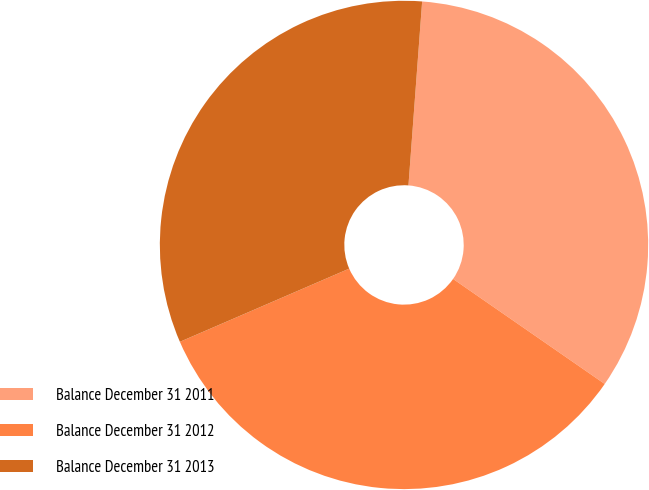<chart> <loc_0><loc_0><loc_500><loc_500><pie_chart><fcel>Balance December 31 2011<fcel>Balance December 31 2012<fcel>Balance December 31 2013<nl><fcel>33.46%<fcel>33.87%<fcel>32.68%<nl></chart> 